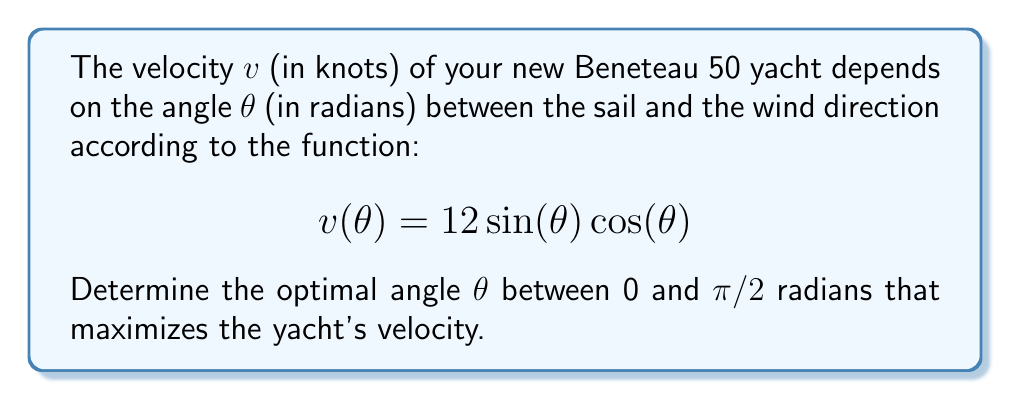Can you solve this math problem? To find the optimal angle that maximizes the yacht's velocity, we need to find the maximum of the given function $v(\theta) = 12 \sin(\theta) \cos(\theta)$ in the interval $[0, \pi/2]$.

Step 1: Simplify the function using the trigonometric identity $\sin(2\theta) = 2\sin(\theta)\cos(\theta)$:
$$v(\theta) = 12 \sin(\theta) \cos(\theta) = 6 \sin(2\theta)$$

Step 2: To find the maximum, we need to find the derivative of $v(\theta)$ and set it equal to zero:
$$v'(\theta) = 6 \cdot 2 \cos(2\theta) = 12 \cos(2\theta)$$

Step 3: Set the derivative equal to zero and solve for $\theta$:
$$12 \cos(2\theta) = 0$$
$$\cos(2\theta) = 0$$

Step 4: Solve the equation:
$$2\theta = \frac{\pi}{2} + n\pi, \text{ where } n \text{ is an integer}$$
$$\theta = \frac{\pi}{4} + \frac{n\pi}{2}$$

Step 5: Given the constraint $0 \leq \theta \leq \pi/2$, the only solution in this interval is:
$$\theta = \frac{\pi}{4}$$

Step 6: Verify that this is indeed a maximum by checking the second derivative:
$$v''(\theta) = -24 \sin(2\theta)$$
At $\theta = \pi/4$, $v''(\pi/4) = -24 \sin(\pi/2) = -24 < 0$, confirming it's a maximum.

Therefore, the optimal angle that maximizes the yacht's velocity is $\pi/4$ radians or 45 degrees.
Answer: $\frac{\pi}{4}$ radians (45°) 